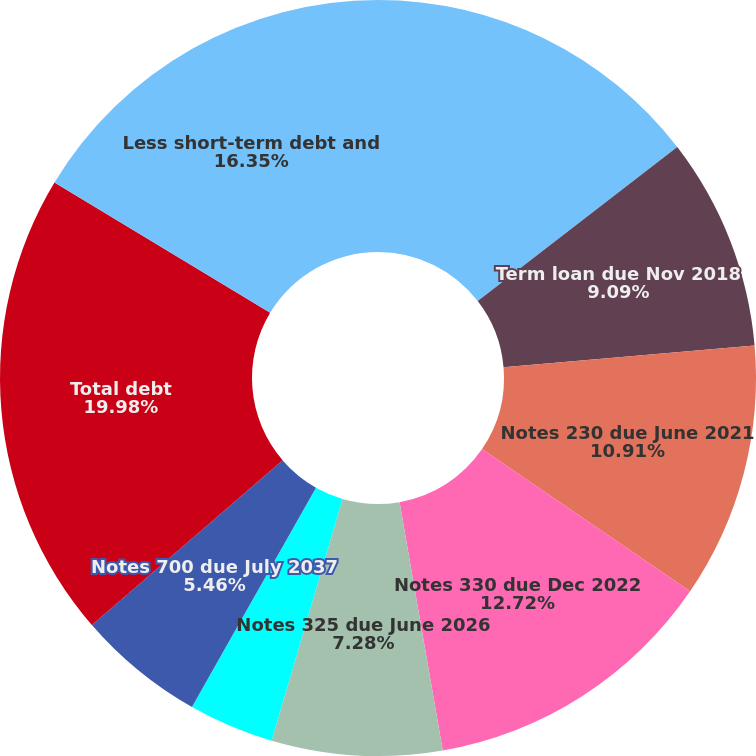Convert chart. <chart><loc_0><loc_0><loc_500><loc_500><pie_chart><fcel>Commercial paper (CP)<fcel>Term loan due Nov 2018<fcel>Notes 230 due June 2021<fcel>Notes 330 due Dec 2022<fcel>Notes 325 due June 2026<fcel>Debentures 690 due July 2028<fcel>Notes 700 due July 2037<fcel>Other<fcel>Total debt<fcel>Less short-term debt and<nl><fcel>14.54%<fcel>9.09%<fcel>10.91%<fcel>12.72%<fcel>7.28%<fcel>3.65%<fcel>5.46%<fcel>0.02%<fcel>19.98%<fcel>16.35%<nl></chart> 